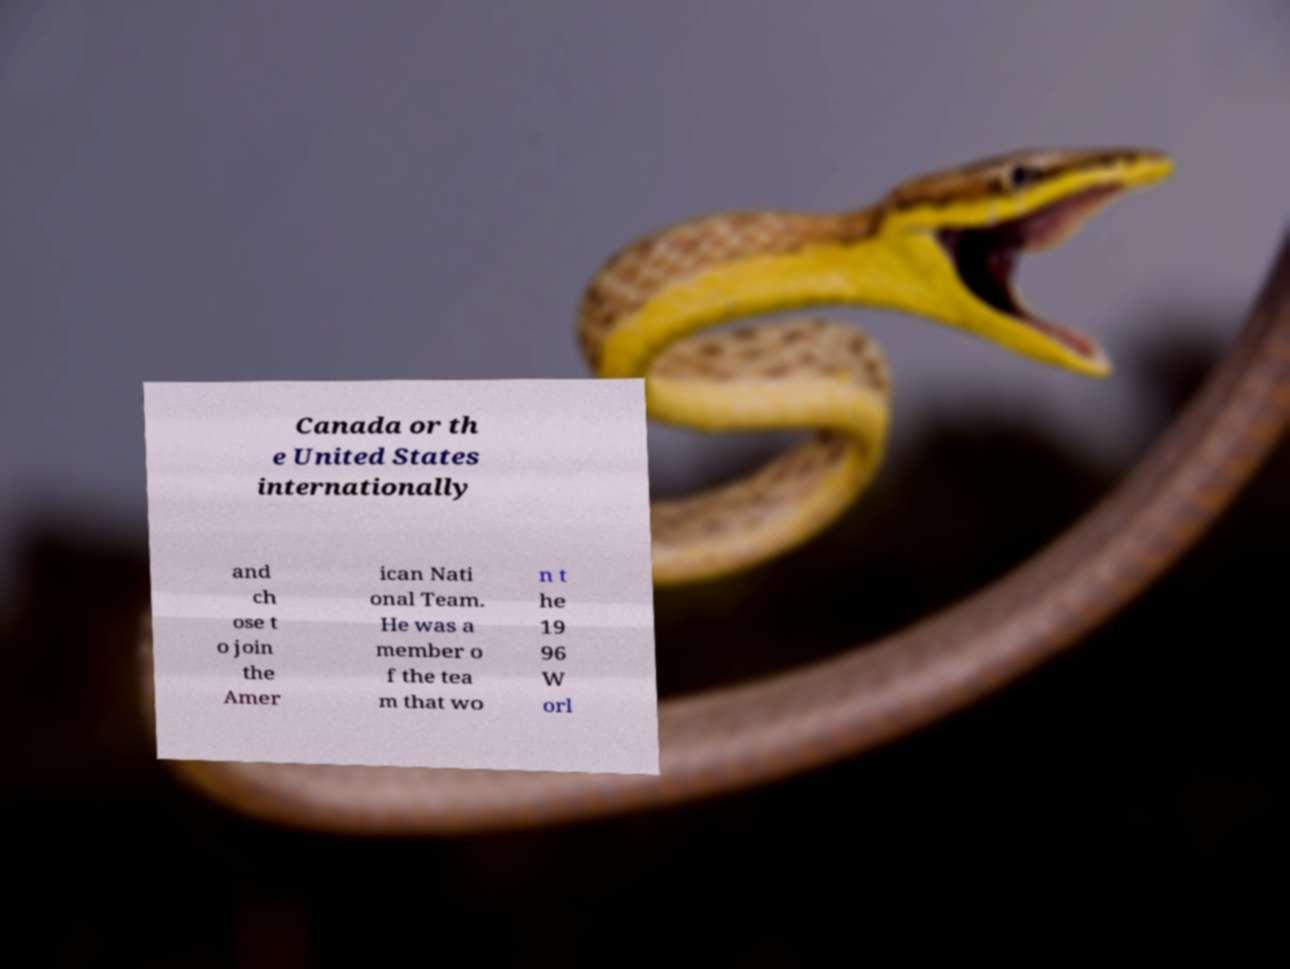What messages or text are displayed in this image? I need them in a readable, typed format. Canada or th e United States internationally and ch ose t o join the Amer ican Nati onal Team. He was a member o f the tea m that wo n t he 19 96 W orl 